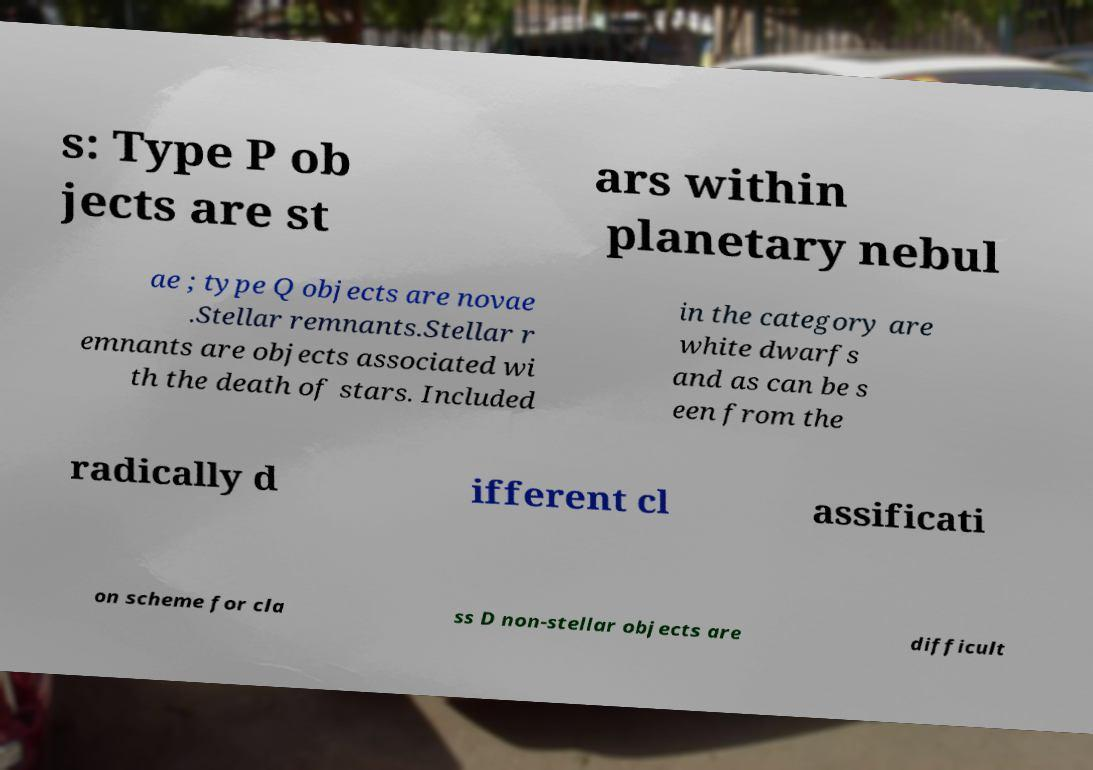Please identify and transcribe the text found in this image. s: Type P ob jects are st ars within planetary nebul ae ; type Q objects are novae .Stellar remnants.Stellar r emnants are objects associated wi th the death of stars. Included in the category are white dwarfs and as can be s een from the radically d ifferent cl assificati on scheme for cla ss D non-stellar objects are difficult 